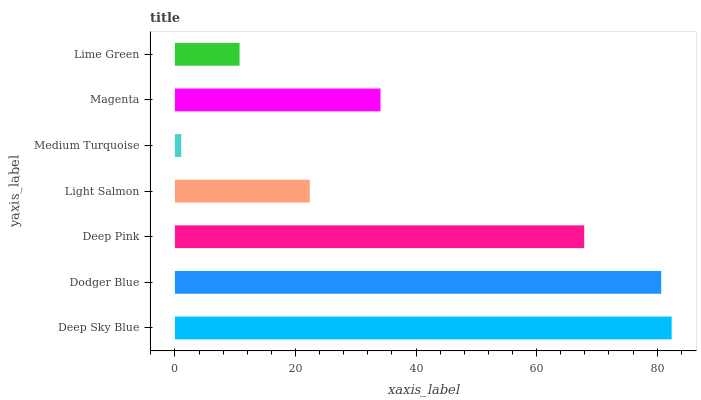Is Medium Turquoise the minimum?
Answer yes or no. Yes. Is Deep Sky Blue the maximum?
Answer yes or no. Yes. Is Dodger Blue the minimum?
Answer yes or no. No. Is Dodger Blue the maximum?
Answer yes or no. No. Is Deep Sky Blue greater than Dodger Blue?
Answer yes or no. Yes. Is Dodger Blue less than Deep Sky Blue?
Answer yes or no. Yes. Is Dodger Blue greater than Deep Sky Blue?
Answer yes or no. No. Is Deep Sky Blue less than Dodger Blue?
Answer yes or no. No. Is Magenta the high median?
Answer yes or no. Yes. Is Magenta the low median?
Answer yes or no. Yes. Is Light Salmon the high median?
Answer yes or no. No. Is Lime Green the low median?
Answer yes or no. No. 